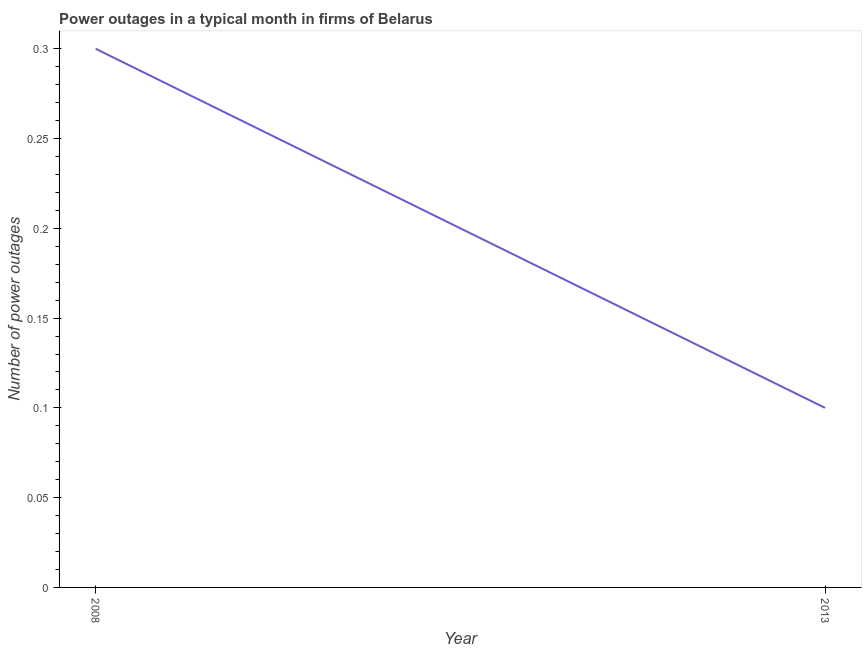What is the number of power outages in 2008?
Provide a short and direct response. 0.3. Across all years, what is the minimum number of power outages?
Your answer should be compact. 0.1. In which year was the number of power outages minimum?
Provide a short and direct response. 2013. What is the sum of the number of power outages?
Your response must be concise. 0.4. What is the difference between the number of power outages in 2008 and 2013?
Keep it short and to the point. 0.2. What is the ratio of the number of power outages in 2008 to that in 2013?
Make the answer very short. 3. In how many years, is the number of power outages greater than the average number of power outages taken over all years?
Give a very brief answer. 1. How many lines are there?
Provide a succinct answer. 1. How many years are there in the graph?
Provide a short and direct response. 2. Does the graph contain grids?
Provide a short and direct response. No. What is the title of the graph?
Make the answer very short. Power outages in a typical month in firms of Belarus. What is the label or title of the Y-axis?
Ensure brevity in your answer.  Number of power outages. What is the Number of power outages of 2008?
Your response must be concise. 0.3. 